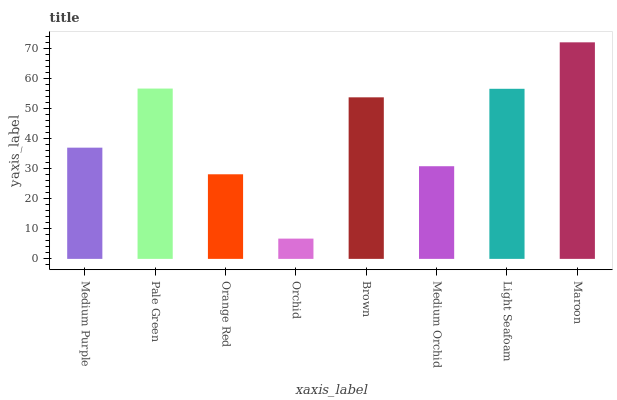Is Orchid the minimum?
Answer yes or no. Yes. Is Maroon the maximum?
Answer yes or no. Yes. Is Pale Green the minimum?
Answer yes or no. No. Is Pale Green the maximum?
Answer yes or no. No. Is Pale Green greater than Medium Purple?
Answer yes or no. Yes. Is Medium Purple less than Pale Green?
Answer yes or no. Yes. Is Medium Purple greater than Pale Green?
Answer yes or no. No. Is Pale Green less than Medium Purple?
Answer yes or no. No. Is Brown the high median?
Answer yes or no. Yes. Is Medium Purple the low median?
Answer yes or no. Yes. Is Orange Red the high median?
Answer yes or no. No. Is Light Seafoam the low median?
Answer yes or no. No. 